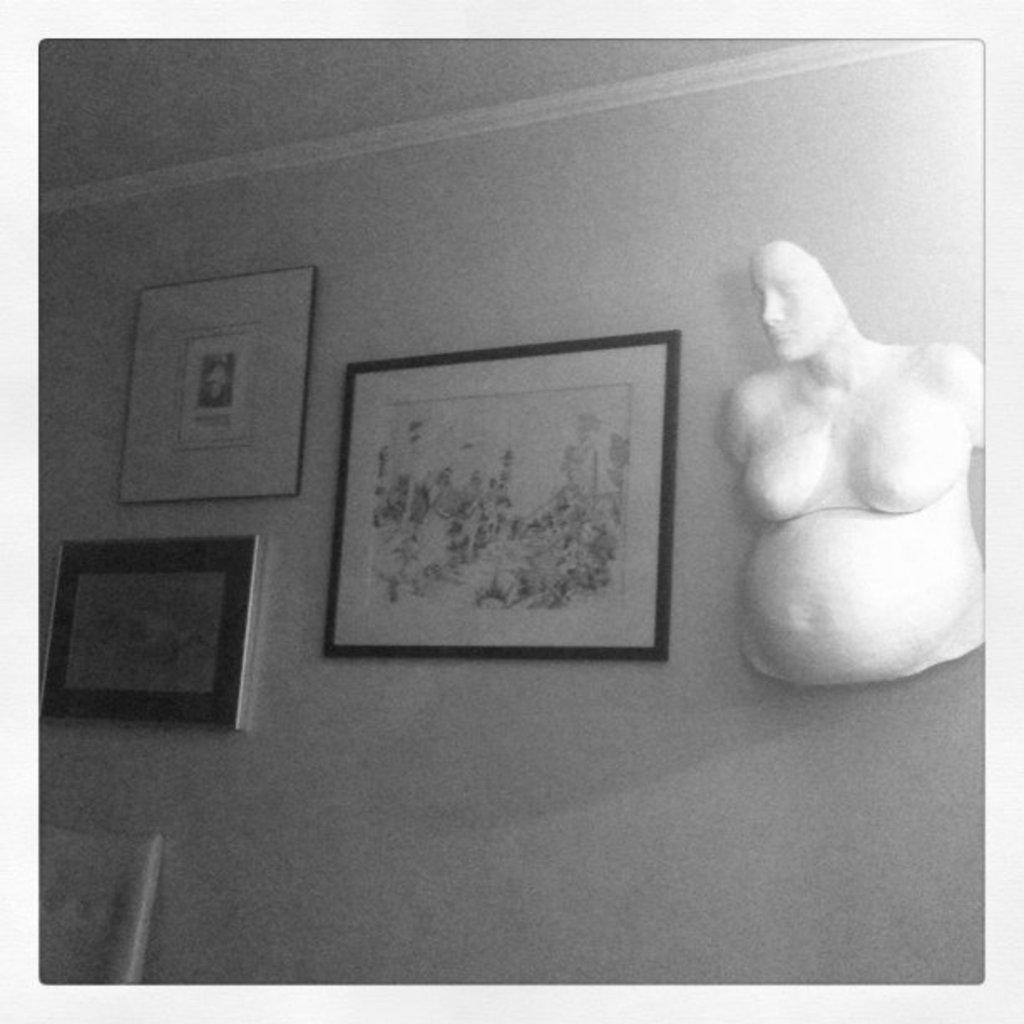What is hanging on the wall in the image? There are photo frames on the wall. Can you see any fairies flying around the photo frames in the image? No, there are no fairies present in the image. 